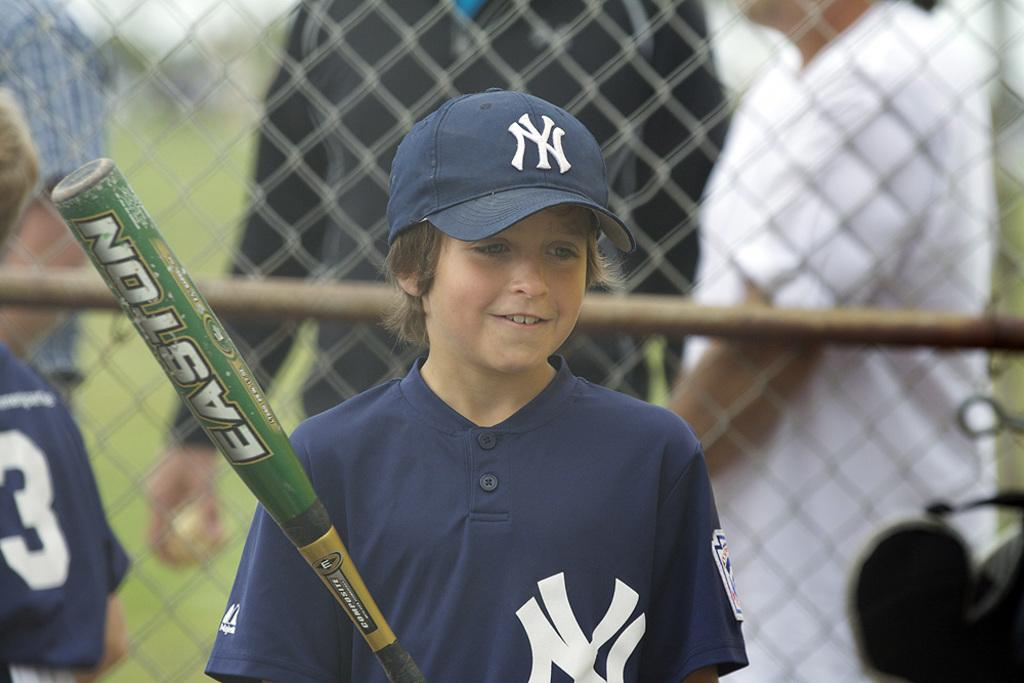<image>
Share a concise interpretation of the image provided. A young boy wears the NY Yankees logo on his shirt and hat 